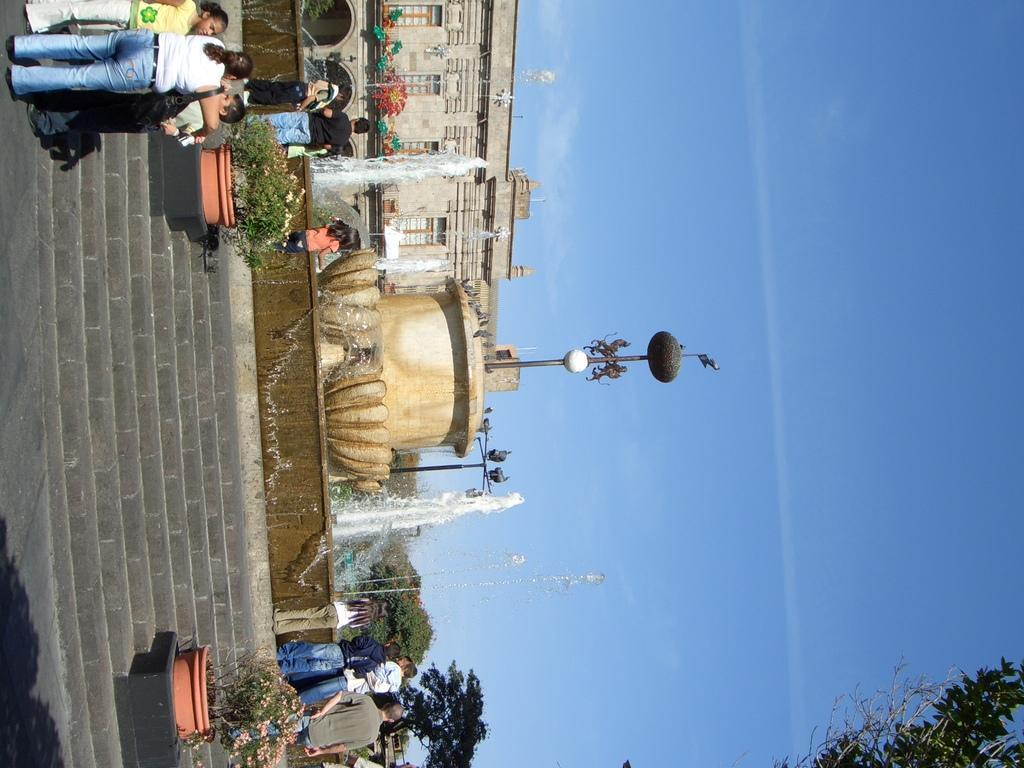Please provide a concise description of this image. In this image we can see a fountain. In front of the fountain we can see a wall, persons, stairs and the plants. Behind the fountain we can see a building and trees. On the right side, we can see the sky. At the bottom we can see the leaves. In the top left, we can see few persons. 